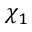<formula> <loc_0><loc_0><loc_500><loc_500>\chi _ { 1 }</formula> 